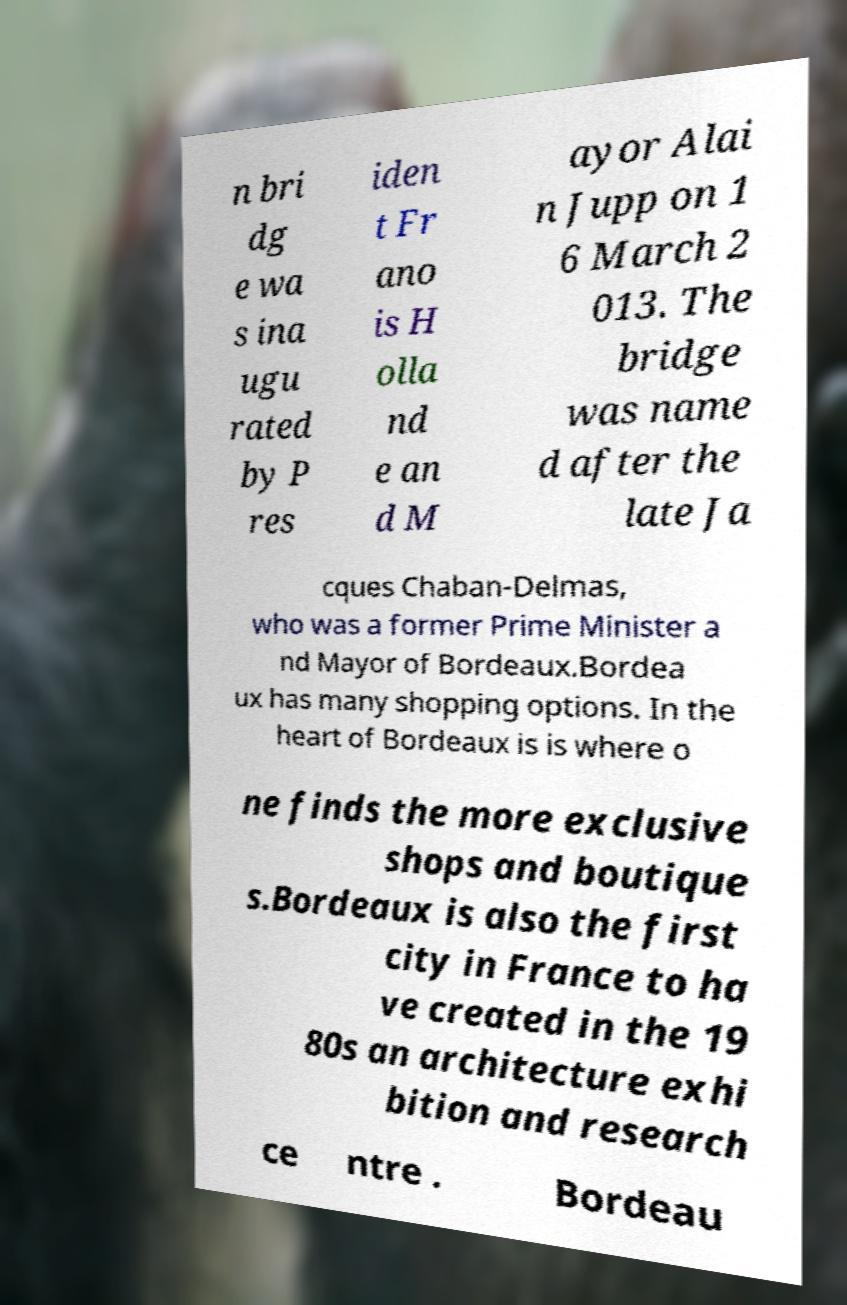What messages or text are displayed in this image? I need them in a readable, typed format. n bri dg e wa s ina ugu rated by P res iden t Fr ano is H olla nd e an d M ayor Alai n Jupp on 1 6 March 2 013. The bridge was name d after the late Ja cques Chaban-Delmas, who was a former Prime Minister a nd Mayor of Bordeaux.Bordea ux has many shopping options. In the heart of Bordeaux is is where o ne finds the more exclusive shops and boutique s.Bordeaux is also the first city in France to ha ve created in the 19 80s an architecture exhi bition and research ce ntre . Bordeau 